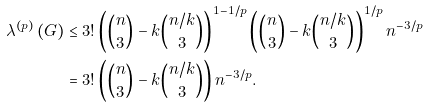Convert formula to latex. <formula><loc_0><loc_0><loc_500><loc_500>\lambda ^ { \left ( p \right ) } \left ( G \right ) & \leq 3 ! \left ( \binom { n } { 3 } - k \binom { n / k } { 3 } \right ) ^ { 1 - 1 / p } \left ( \binom { n } { 3 } - k \binom { n / k } { 3 } \right ) ^ { 1 / p } n ^ { - 3 / p } \\ & = 3 ! \left ( \binom { n } { 3 } - k \binom { n / k } { 3 } \right ) n ^ { - 3 / p } .</formula> 